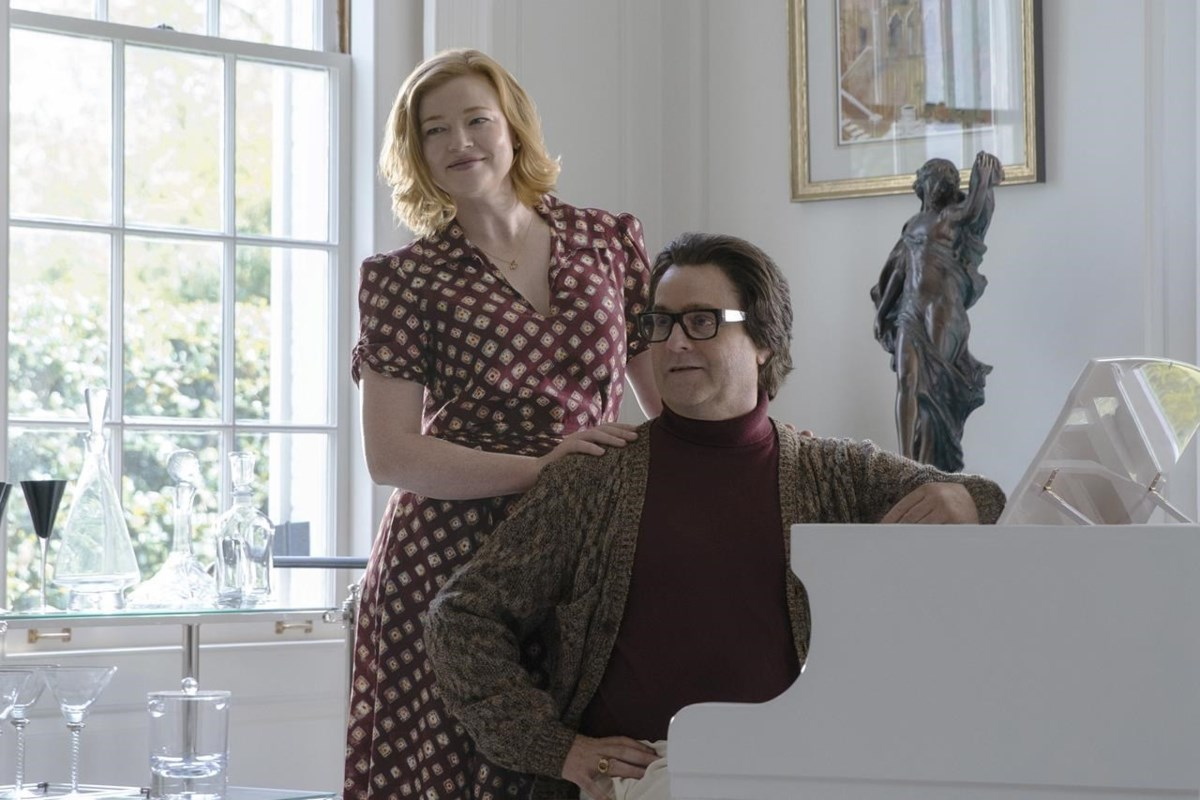Describe the environment in terms of décor and ambiance. Is it reflective of any particular style or era? The environment in this image exudes a classic and elegant ambiance, with some hints of modern touches. The white piano and the white curtains add a contemporary feel, contrasting subtly with more timeless pieces of decor like the statue and the framed artwork on the wall. The overall aesthetic suggests a blend of modern minimalism with classical elegance. The room is bright and airy, likely due to the large window that allows natural light to flood in, enhancing the soft and serene atmosphere. The presence of art pieces indicates an appreciation for culture and fine tastes, making the environment sophisticated yet welcoming. 